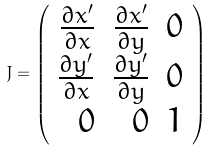<formula> <loc_0><loc_0><loc_500><loc_500>J = \left ( \begin{array} { r r r } \frac { \partial x ^ { \prime } } { \partial x } & \frac { \partial x ^ { \prime } } { \partial y } & 0 \\ \frac { \partial y ^ { \prime } } { \partial x } & \frac { \partial y ^ { \prime } } { \partial y } & 0 \\ 0 & 0 & 1 \end{array} \right )</formula> 